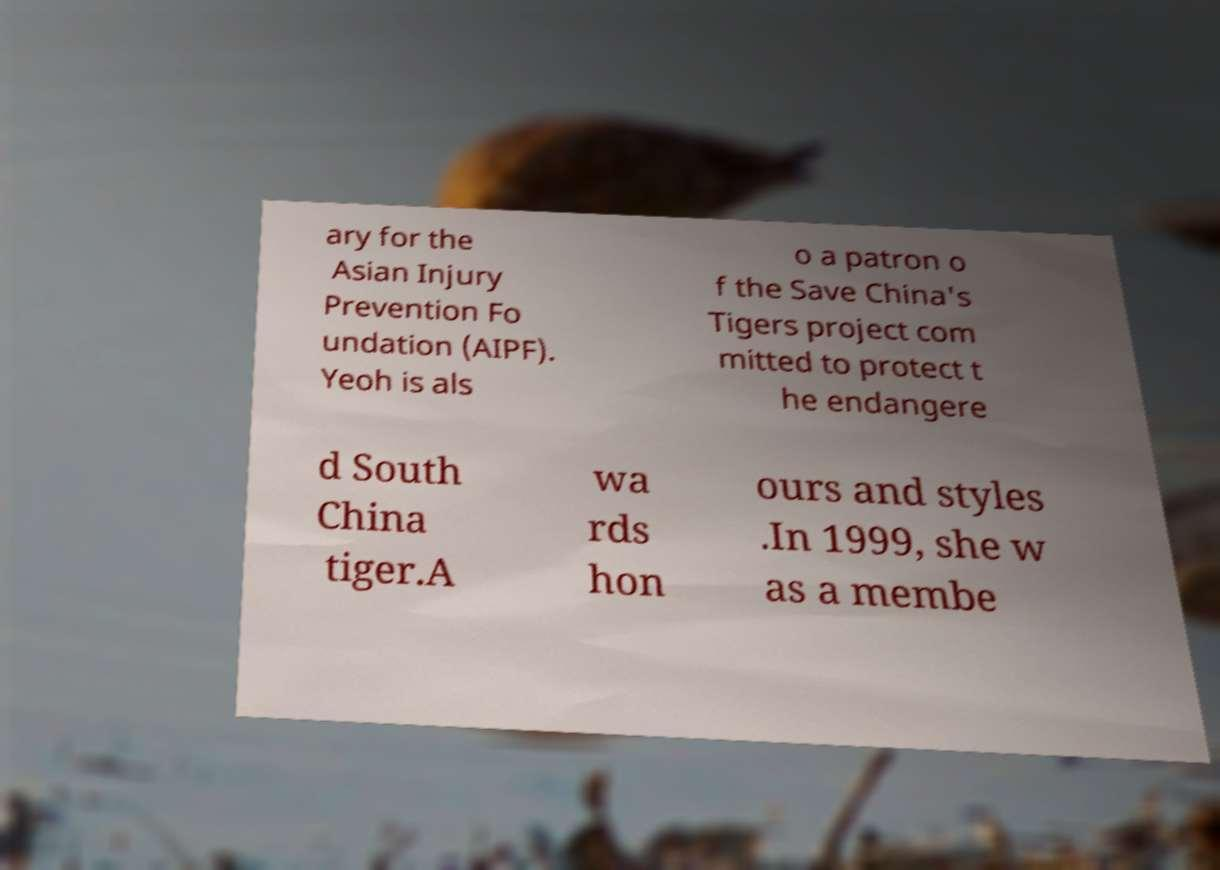I need the written content from this picture converted into text. Can you do that? ary for the Asian Injury Prevention Fo undation (AIPF). Yeoh is als o a patron o f the Save China's Tigers project com mitted to protect t he endangere d South China tiger.A wa rds hon ours and styles .In 1999, she w as a membe 